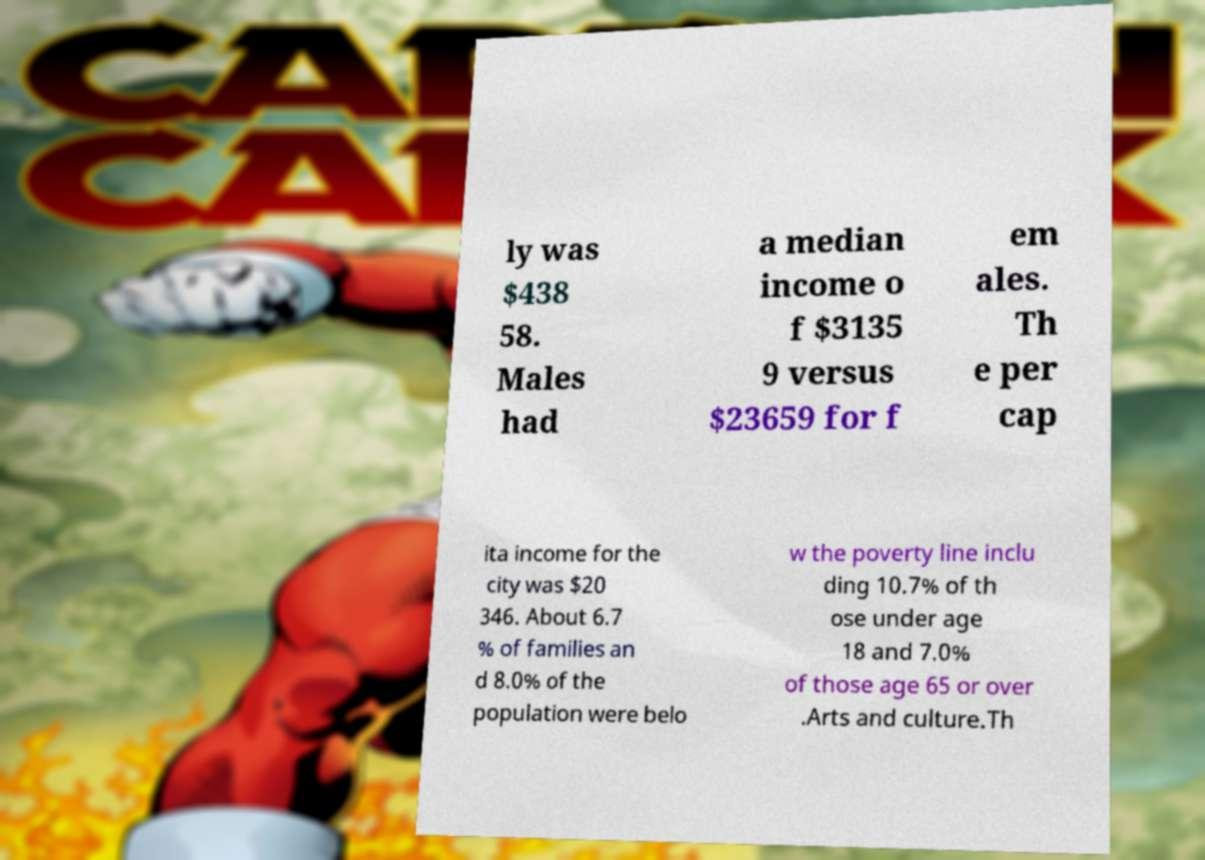Could you extract and type out the text from this image? ly was $438 58. Males had a median income o f $3135 9 versus $23659 for f em ales. Th e per cap ita income for the city was $20 346. About 6.7 % of families an d 8.0% of the population were belo w the poverty line inclu ding 10.7% of th ose under age 18 and 7.0% of those age 65 or over .Arts and culture.Th 